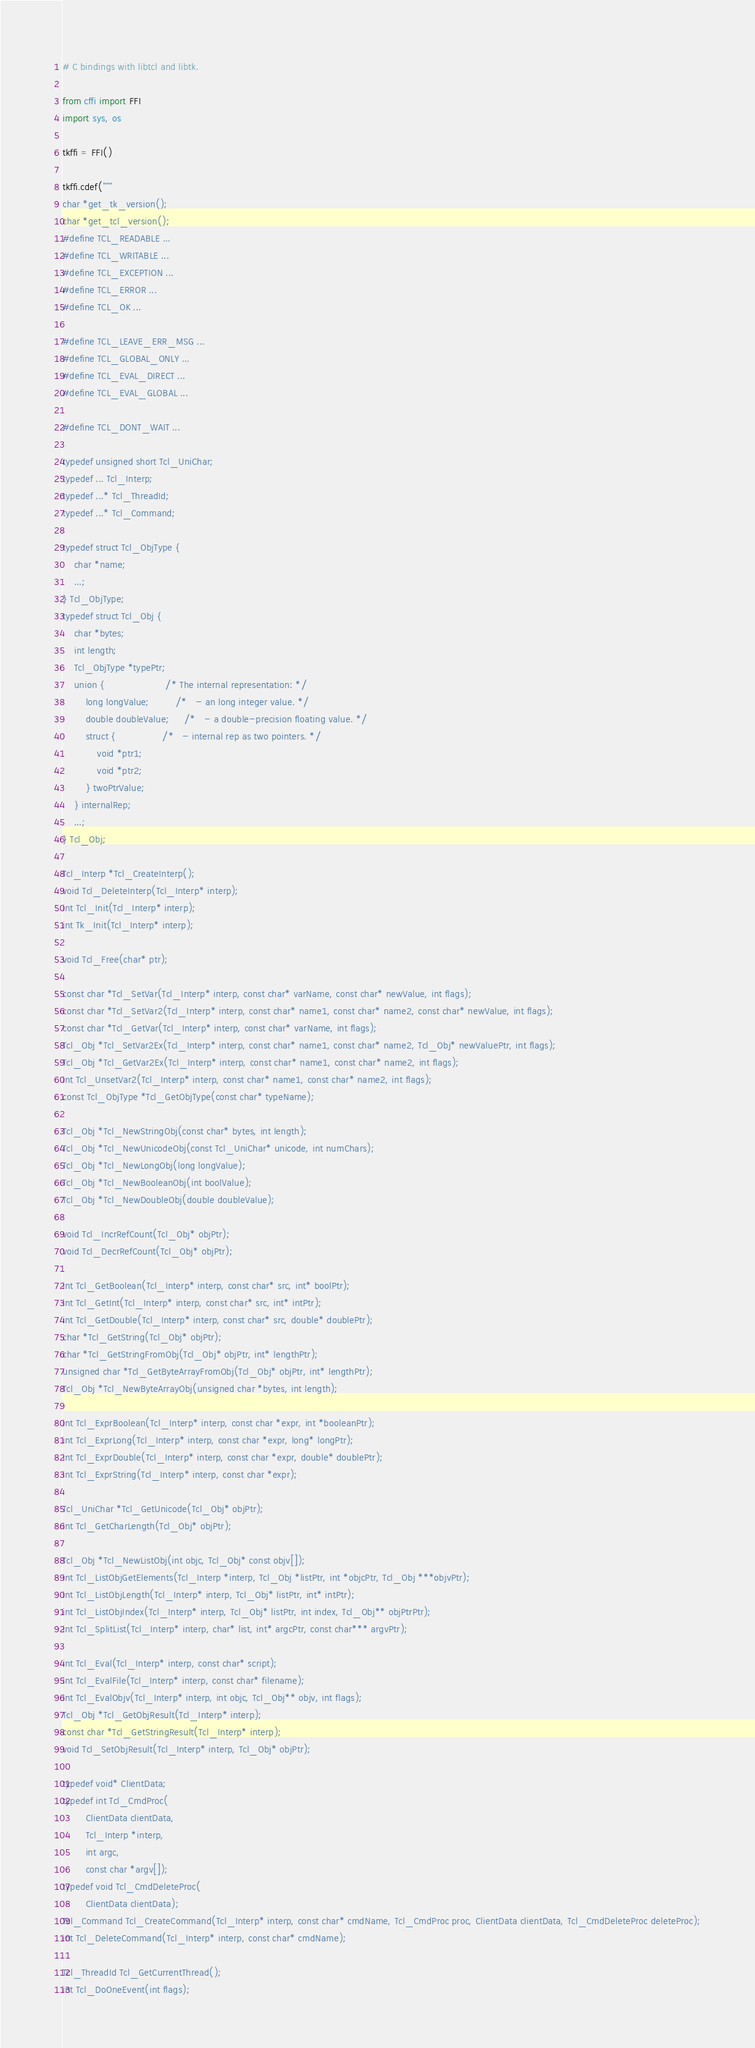Convert code to text. <code><loc_0><loc_0><loc_500><loc_500><_Python_># C bindings with libtcl and libtk.

from cffi import FFI
import sys, os

tkffi = FFI()

tkffi.cdef("""
char *get_tk_version();
char *get_tcl_version();
#define TCL_READABLE ...
#define TCL_WRITABLE ...
#define TCL_EXCEPTION ...
#define TCL_ERROR ...
#define TCL_OK ...

#define TCL_LEAVE_ERR_MSG ...
#define TCL_GLOBAL_ONLY ...
#define TCL_EVAL_DIRECT ...
#define TCL_EVAL_GLOBAL ...

#define TCL_DONT_WAIT ...

typedef unsigned short Tcl_UniChar;
typedef ... Tcl_Interp;
typedef ...* Tcl_ThreadId;
typedef ...* Tcl_Command;

typedef struct Tcl_ObjType {
    char *name;
    ...;
} Tcl_ObjType;
typedef struct Tcl_Obj {
    char *bytes;
    int length;
    Tcl_ObjType *typePtr;
    union {                     /* The internal representation: */
        long longValue;         /*   - an long integer value. */
        double doubleValue;     /*   - a double-precision floating value. */
        struct {                /*   - internal rep as two pointers. */
            void *ptr1;
            void *ptr2;
        } twoPtrValue;
    } internalRep;
    ...;
} Tcl_Obj;

Tcl_Interp *Tcl_CreateInterp();
void Tcl_DeleteInterp(Tcl_Interp* interp);
int Tcl_Init(Tcl_Interp* interp);
int Tk_Init(Tcl_Interp* interp);

void Tcl_Free(char* ptr);

const char *Tcl_SetVar(Tcl_Interp* interp, const char* varName, const char* newValue, int flags);
const char *Tcl_SetVar2(Tcl_Interp* interp, const char* name1, const char* name2, const char* newValue, int flags);
const char *Tcl_GetVar(Tcl_Interp* interp, const char* varName, int flags);
Tcl_Obj *Tcl_SetVar2Ex(Tcl_Interp* interp, const char* name1, const char* name2, Tcl_Obj* newValuePtr, int flags);
Tcl_Obj *Tcl_GetVar2Ex(Tcl_Interp* interp, const char* name1, const char* name2, int flags);
int Tcl_UnsetVar2(Tcl_Interp* interp, const char* name1, const char* name2, int flags);
const Tcl_ObjType *Tcl_GetObjType(const char* typeName);

Tcl_Obj *Tcl_NewStringObj(const char* bytes, int length);
Tcl_Obj *Tcl_NewUnicodeObj(const Tcl_UniChar* unicode, int numChars);
Tcl_Obj *Tcl_NewLongObj(long longValue);
Tcl_Obj *Tcl_NewBooleanObj(int boolValue);
Tcl_Obj *Tcl_NewDoubleObj(double doubleValue);

void Tcl_IncrRefCount(Tcl_Obj* objPtr);
void Tcl_DecrRefCount(Tcl_Obj* objPtr);

int Tcl_GetBoolean(Tcl_Interp* interp, const char* src, int* boolPtr);
int Tcl_GetInt(Tcl_Interp* interp, const char* src, int* intPtr);
int Tcl_GetDouble(Tcl_Interp* interp, const char* src, double* doublePtr);
char *Tcl_GetString(Tcl_Obj* objPtr);
char *Tcl_GetStringFromObj(Tcl_Obj* objPtr, int* lengthPtr);
unsigned char *Tcl_GetByteArrayFromObj(Tcl_Obj* objPtr, int* lengthPtr);
Tcl_Obj *Tcl_NewByteArrayObj(unsigned char *bytes, int length);

int Tcl_ExprBoolean(Tcl_Interp* interp, const char *expr, int *booleanPtr);
int Tcl_ExprLong(Tcl_Interp* interp, const char *expr, long* longPtr);
int Tcl_ExprDouble(Tcl_Interp* interp, const char *expr, double* doublePtr);
int Tcl_ExprString(Tcl_Interp* interp, const char *expr);

Tcl_UniChar *Tcl_GetUnicode(Tcl_Obj* objPtr);
int Tcl_GetCharLength(Tcl_Obj* objPtr);

Tcl_Obj *Tcl_NewListObj(int objc, Tcl_Obj* const objv[]);
int Tcl_ListObjGetElements(Tcl_Interp *interp, Tcl_Obj *listPtr, int *objcPtr, Tcl_Obj ***objvPtr);
int Tcl_ListObjLength(Tcl_Interp* interp, Tcl_Obj* listPtr, int* intPtr);
int Tcl_ListObjIndex(Tcl_Interp* interp, Tcl_Obj* listPtr, int index, Tcl_Obj** objPtrPtr);
int Tcl_SplitList(Tcl_Interp* interp, char* list, int* argcPtr, const char*** argvPtr);

int Tcl_Eval(Tcl_Interp* interp, const char* script);
int Tcl_EvalFile(Tcl_Interp* interp, const char* filename);
int Tcl_EvalObjv(Tcl_Interp* interp, int objc, Tcl_Obj** objv, int flags);
Tcl_Obj *Tcl_GetObjResult(Tcl_Interp* interp);
const char *Tcl_GetStringResult(Tcl_Interp* interp);
void Tcl_SetObjResult(Tcl_Interp* interp, Tcl_Obj* objPtr);

typedef void* ClientData;
typedef int Tcl_CmdProc(
        ClientData clientData,
        Tcl_Interp *interp,
        int argc,
        const char *argv[]);
typedef void Tcl_CmdDeleteProc(
        ClientData clientData);
Tcl_Command Tcl_CreateCommand(Tcl_Interp* interp, const char* cmdName, Tcl_CmdProc proc, ClientData clientData, Tcl_CmdDeleteProc deleteProc);
int Tcl_DeleteCommand(Tcl_Interp* interp, const char* cmdName);

Tcl_ThreadId Tcl_GetCurrentThread();
int Tcl_DoOneEvent(int flags);
</code> 